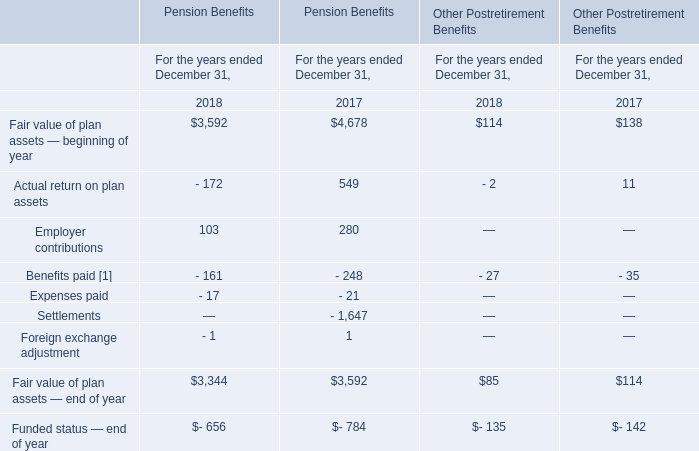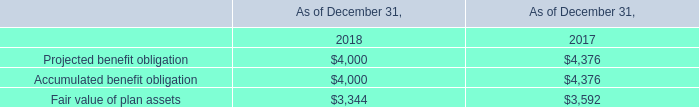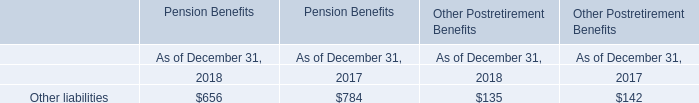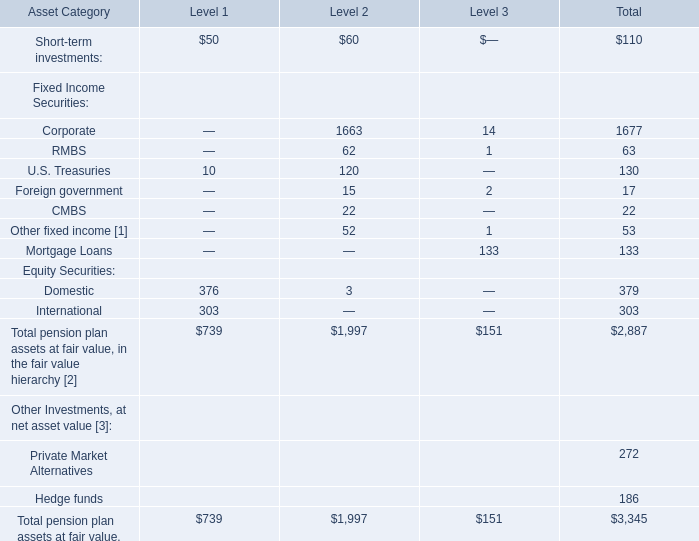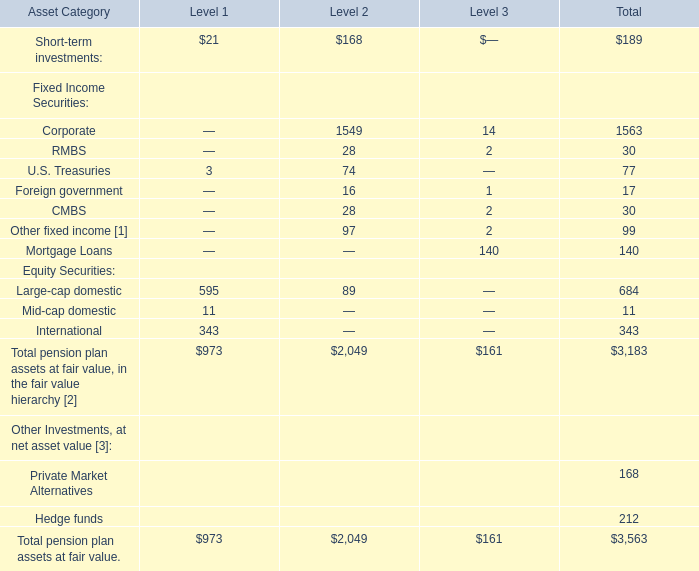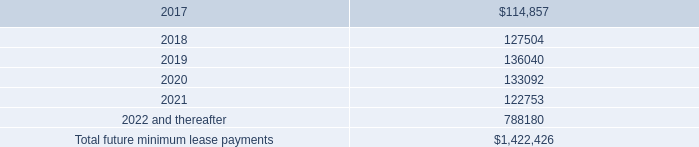The Total pension plan assets at fair value. of which level ranks first? 
Answer: 2. 